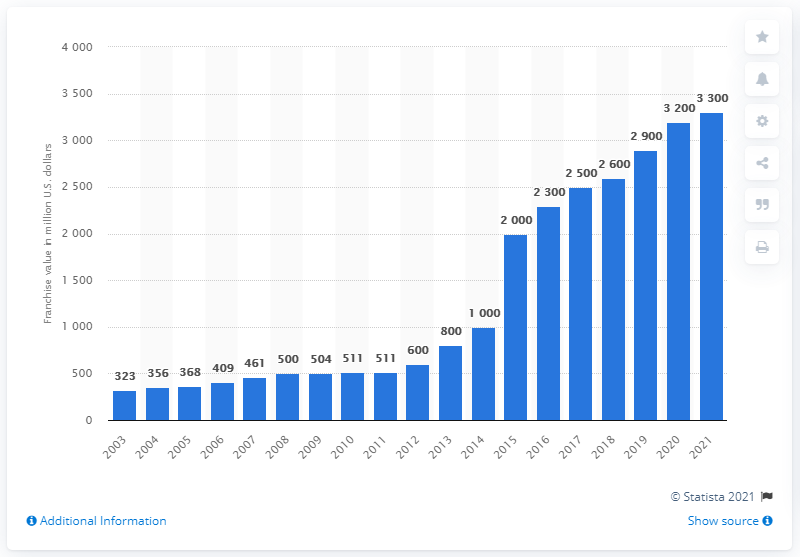Outline some significant characteristics in this image. In 2021, the estimated value of the Chicago Bulls franchise was approximately 3,300. 